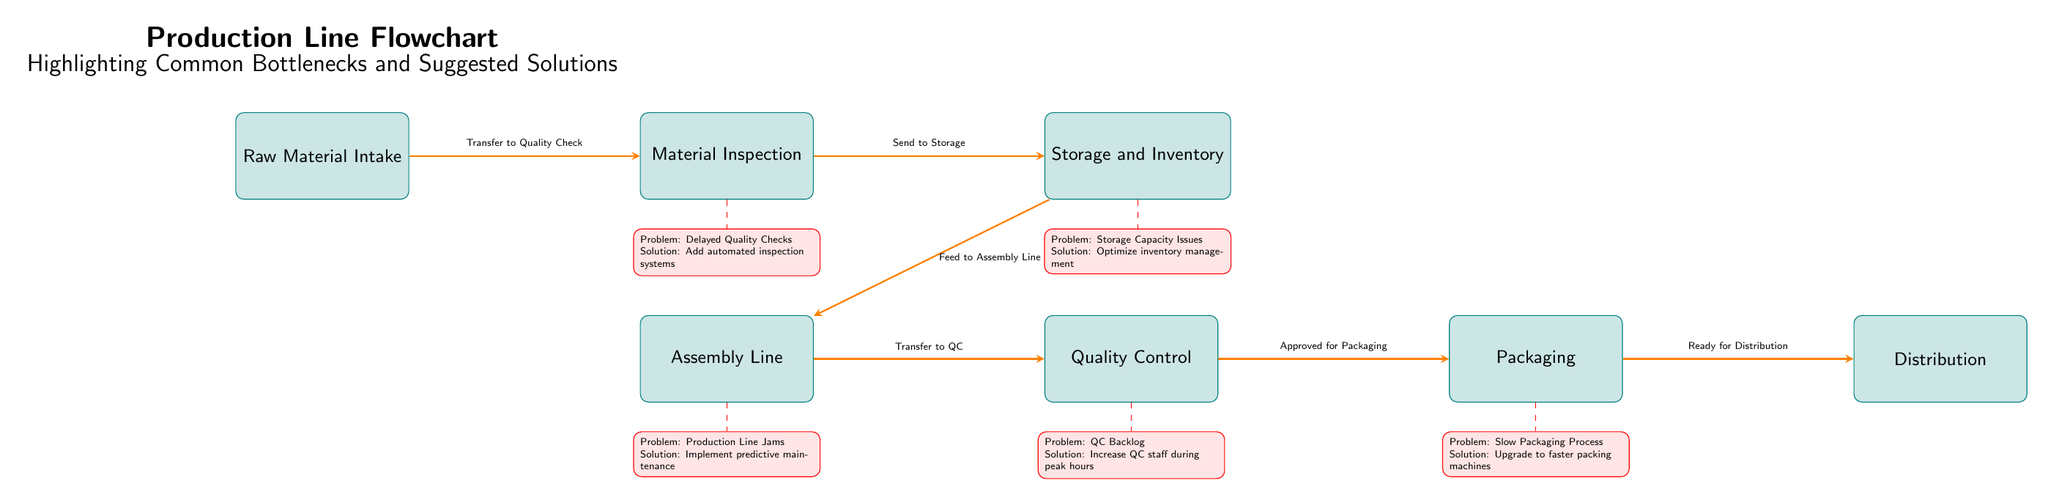What is the first step in the production line? The first step is labeled as "Raw Material Intake" at the leftmost node of the diagram, indicating it is the starting point of the flowchart.
Answer: Raw Material Intake How many nodes are present in the diagram? By counting the boxes representing the various stages in the production line, there are a total of seven nodes visible in the diagram.
Answer: 7 What is the problem noted for Material Inspection? The diagram indicates a bottleneck below the Material Inspection node, stating the problem as "Delayed Quality Checks".
Answer: Delayed Quality Checks What solution is suggested for storage capacity issues? The solution linked to the storage capacity issues, located beneath the Storage and Inventory node, is stated as "Optimize inventory management".
Answer: Optimize inventory management What flows into the Assembly Line from Storage? According to the diagram, the flow from Storage to the Assembly Line is labeled "Feed to Assembly Line".
Answer: Feed to Assembly Line What relationship exists between Quality Control and Packaging? The diagram connects Quality Control to Packaging with the flow labeled "Approved for Packaging", indicating that only approved products move to packaging.
Answer: Approved for Packaging What is the suggested solution for the slow packaging process? The bottleneck below the Packaging node indicates that the suggested solution for the slow packaging process is to "Upgrade to faster packing machines".
Answer: Upgrade to faster packing machines How many bottleneck problems are identified in the diagram? There are five bottleneck problems identified in the diagram, corresponding to each stage of the production process after material inspection.
Answer: 5 Which bottleneck suggests increasing QC staff? The bottleneck associated with Quality Control mentions the problem as "QC Backlog" and suggests the solution to "Increase QC staff during peak hours".
Answer: Increase QC staff during peak hours 